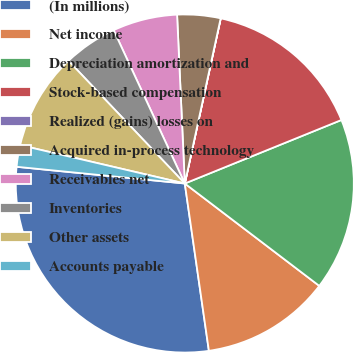Convert chart to OTSL. <chart><loc_0><loc_0><loc_500><loc_500><pie_chart><fcel>(In millions)<fcel>Net income<fcel>Depreciation amortization and<fcel>Stock-based compensation<fcel>Realized (gains) losses on<fcel>Acquired in-process technology<fcel>Receivables net<fcel>Inventories<fcel>Other assets<fcel>Accounts payable<nl><fcel>28.86%<fcel>12.37%<fcel>16.49%<fcel>15.46%<fcel>0.01%<fcel>4.13%<fcel>6.19%<fcel>5.16%<fcel>9.28%<fcel>2.07%<nl></chart> 